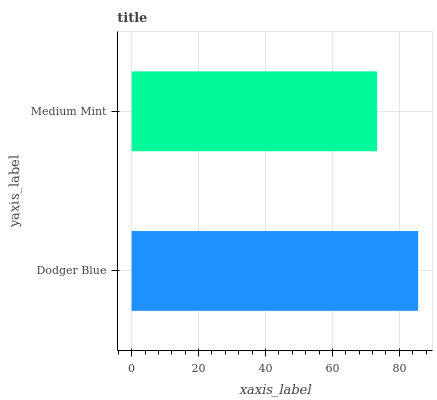Is Medium Mint the minimum?
Answer yes or no. Yes. Is Dodger Blue the maximum?
Answer yes or no. Yes. Is Medium Mint the maximum?
Answer yes or no. No. Is Dodger Blue greater than Medium Mint?
Answer yes or no. Yes. Is Medium Mint less than Dodger Blue?
Answer yes or no. Yes. Is Medium Mint greater than Dodger Blue?
Answer yes or no. No. Is Dodger Blue less than Medium Mint?
Answer yes or no. No. Is Dodger Blue the high median?
Answer yes or no. Yes. Is Medium Mint the low median?
Answer yes or no. Yes. Is Medium Mint the high median?
Answer yes or no. No. Is Dodger Blue the low median?
Answer yes or no. No. 